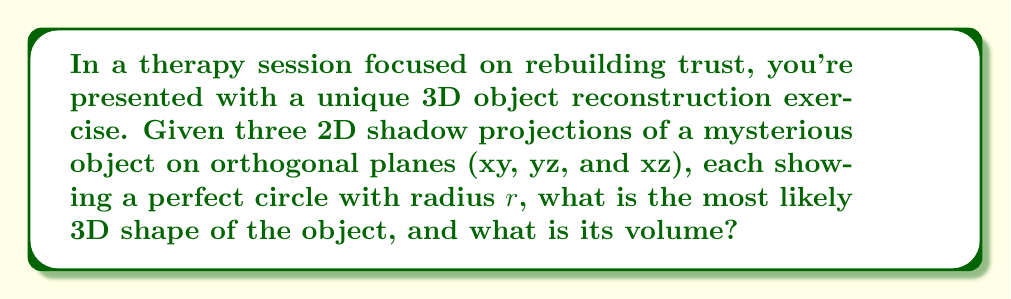Give your solution to this math problem. Let's approach this step-by-step:

1) First, we need to understand what kind of 3D object could cast circular shadows on all three orthogonal planes. The most likely shape is a sphere.

2) A sphere would cast circular shadows of equal size on all planes, which matches our given information.

3) The radius of the sphere would be equal to the radius of the circular shadows, $r$.

4) To calculate the volume of a sphere, we use the formula:

   $$V = \frac{4}{3}\pi r^3$$

5) Since we're given the radius $r$, we can directly substitute this into our formula.

6) The final volume will be expressed in terms of $r^3$.

This exercise demonstrates how we can reconstruct a 3D shape from multiple 2D projections, which is a fundamental concept in inverse problems. It also metaphorically relates to the process of rebuilding trust and self-image, piece by piece, from different perspectives.
Answer: Sphere with volume $\frac{4}{3}\pi r^3$ 